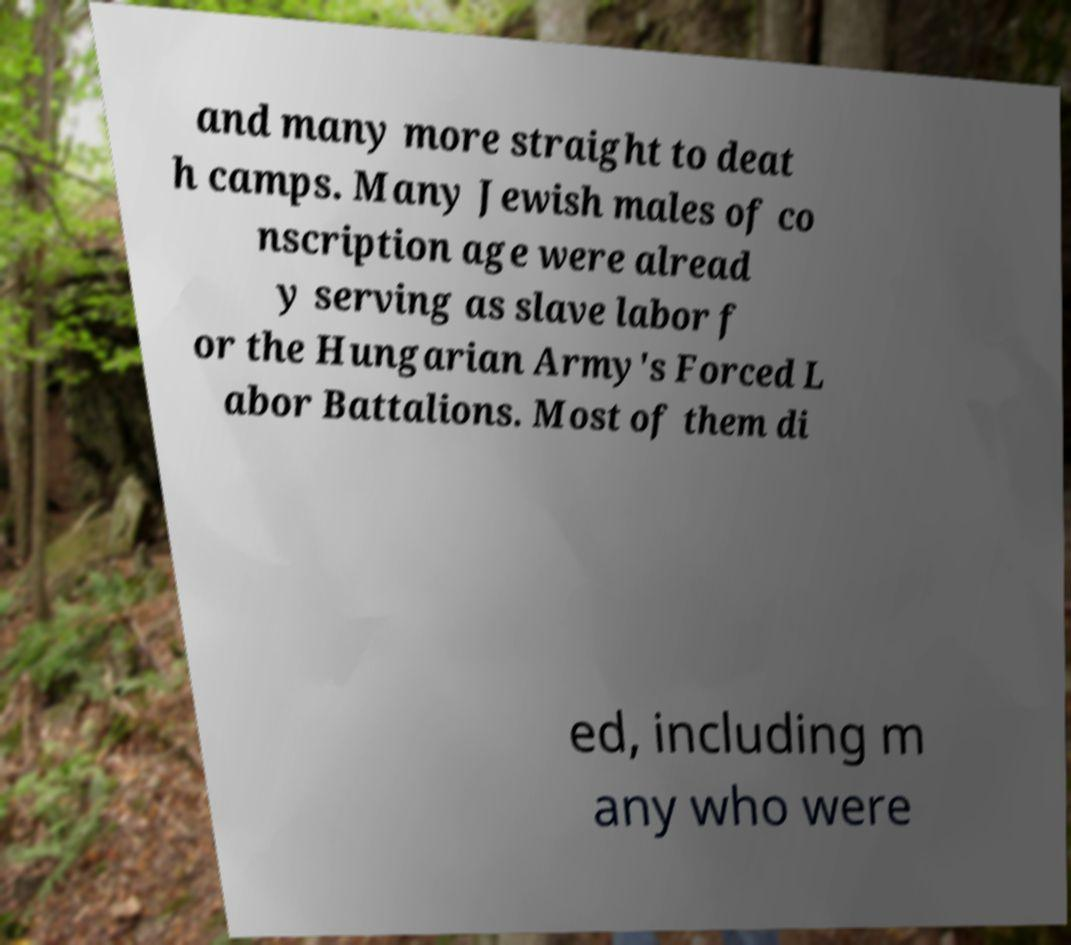Could you assist in decoding the text presented in this image and type it out clearly? and many more straight to deat h camps. Many Jewish males of co nscription age were alread y serving as slave labor f or the Hungarian Army's Forced L abor Battalions. Most of them di ed, including m any who were 